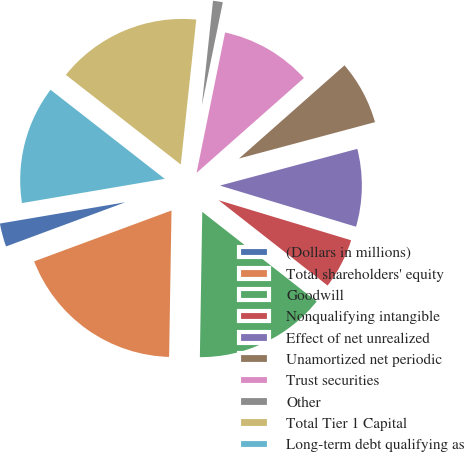Convert chart. <chart><loc_0><loc_0><loc_500><loc_500><pie_chart><fcel>(Dollars in millions)<fcel>Total shareholders' equity<fcel>Goodwill<fcel>Nonqualifying intangible<fcel>Effect of net unrealized<fcel>Unamortized net periodic<fcel>Trust securities<fcel>Other<fcel>Total Tier 1 Capital<fcel>Long-term debt qualifying as<nl><fcel>2.97%<fcel>19.09%<fcel>14.69%<fcel>5.9%<fcel>8.83%<fcel>7.36%<fcel>10.29%<fcel>1.5%<fcel>16.15%<fcel>13.22%<nl></chart> 